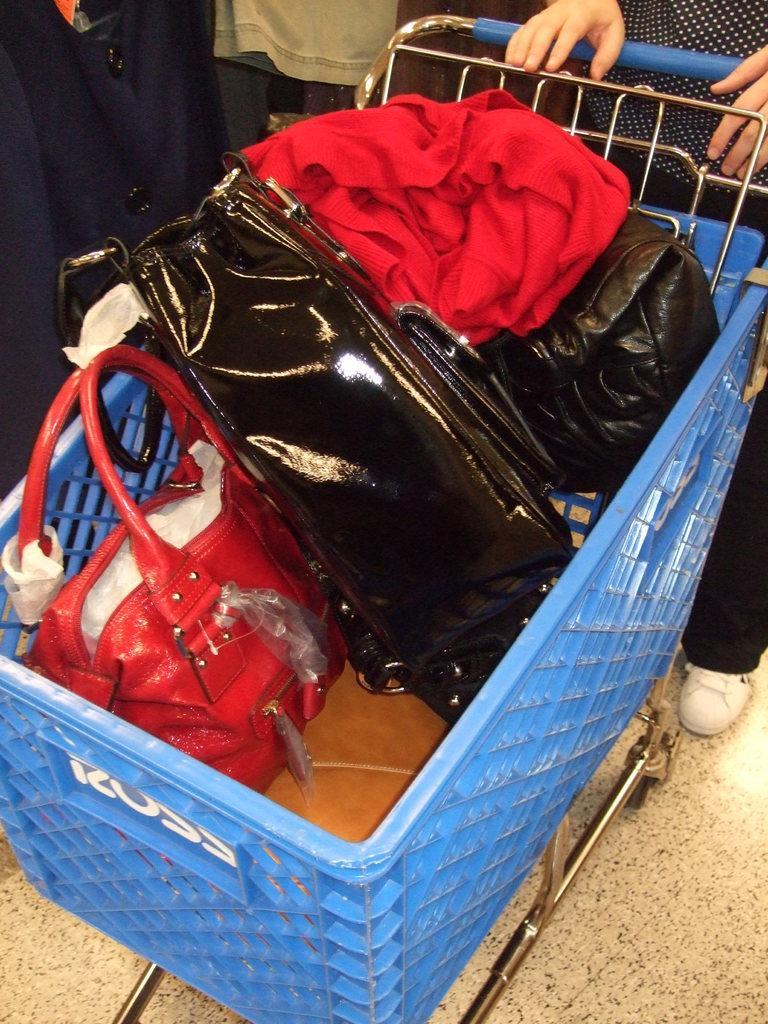In one or two sentences, can you explain what this image depicts? There is a trolley, with a few bags in it. One is in red and the other two are in black. There is red garment. A woman is pushing the trolley with a shirt of white dots in the black background and black pant. She wears white shoes. 